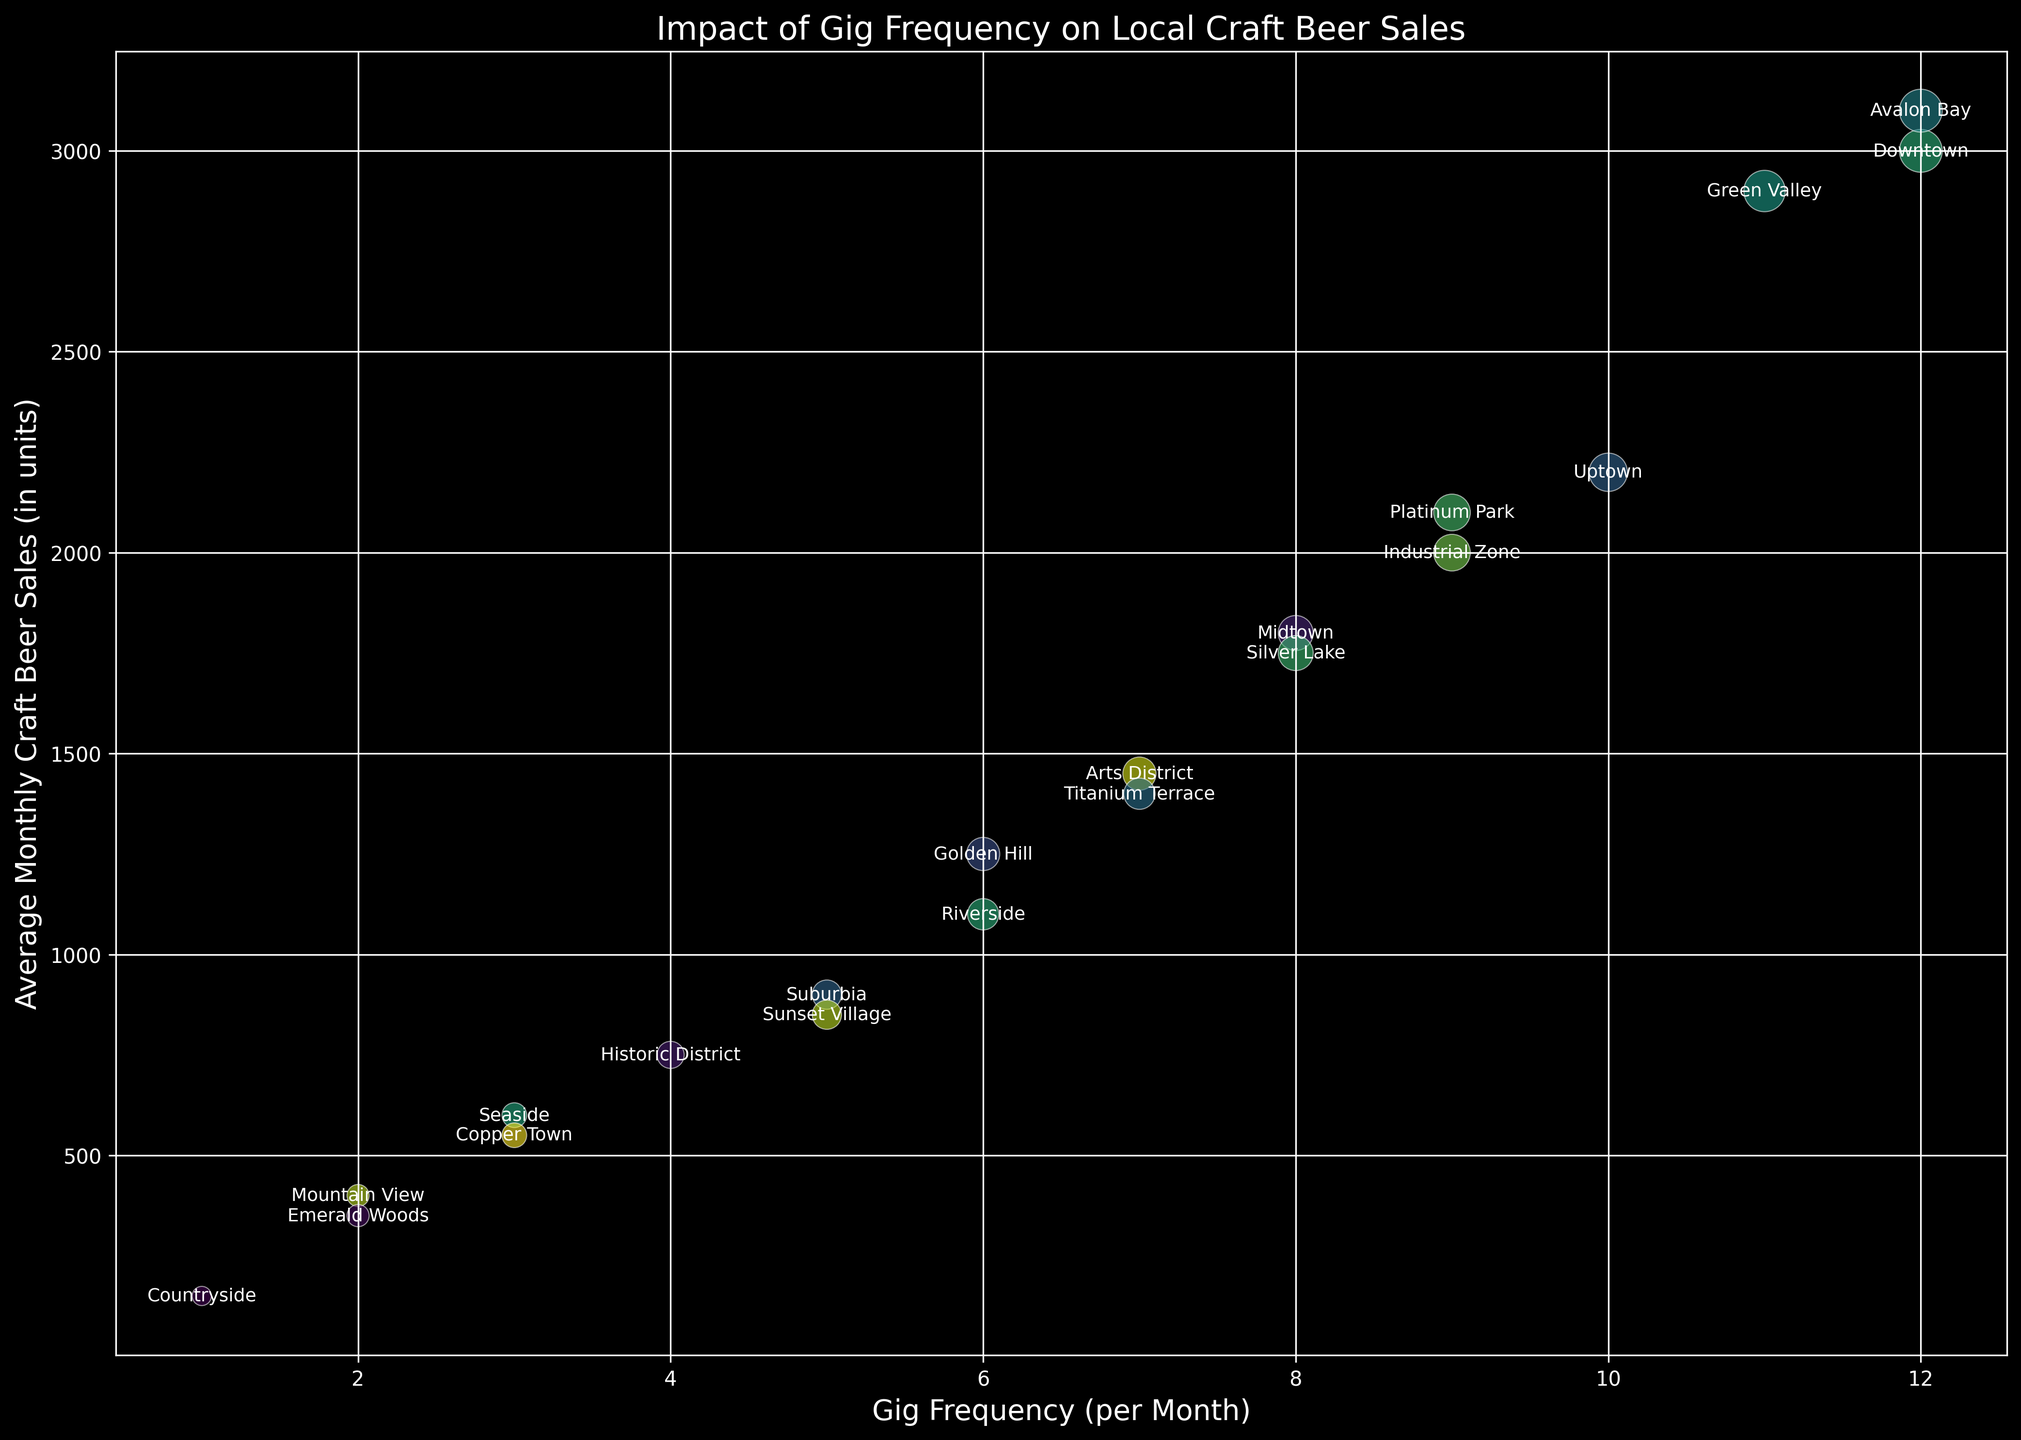Which neighborhood has the highest average monthly craft beer sales? Looking at the bubble chart and identifying the highest Y-axis value, Downtown and Avalon Bay have the highest average monthly craft beer sales at 3100 units.
Answer: Downtown and Avalon Bay Which neighborhood has the lowest gig frequency per month? Observing the X-axis, Countryside has the lowest gig frequency with 1 gig per month.
Answer: Countryside What's the difference in average monthly craft beer sales between Seaside and Copper Town? Seaside has 600 units and Copper Town has 550 units. The difference is 600 - 550 = 50 units.
Answer: 50 units Which neighborhoods have a gig frequency greater than 10? From the X-axis, Downtown (12), Avalon Bay (12), and Green Valley (11) have a gig frequency greater than 10.
Answer: Downtown, Avalon Bay, and Green Valley What is the average gig frequency for Downtown, Midtown, and Uptown? Summing the frequencies for Downtown (12), Midtown (8), and Uptown (10) gives 12 + 8 + 10 = 30. The average is 30 / 3 = 10.
Answer: 10 How many neighborhoods have average monthly craft beer sales greater than 2000 units? From the Y-axis, the neighborhoods are Downtown (3000), Uptown (2200), Industrial Zone (2000), Green Valley (2900), Avalon Bay (3100), and Platinum Park (2100). 6 neighborhoods.
Answer: 6 Which neighborhood has a larger bubble size, Arts District or Golden Hill? By observing the bubble sizes, Arts District has a size of 9, and Golden Hill has a bubble size of 9 as well. So both have equal bubble sizes.
Answer: They are equal Compare beer sales between Riverside and Arts District. Riverside has 1100 units and Arts District has 1450 units. Arts District has higher sales by 1450 - 1100 = 350 units.
Answer: Arts District What's the sum of the population in Seaside and Mountain View? Seaside has a population of 15000 and Mountain View has 12000. The sum is 15000 + 12000 = 27000.
Answer: 27000 Which neighborhood represents the smallest bubble size? Observing the bubble sizes, Countryside has the smallest bubble size of 3.
Answer: Countryside 